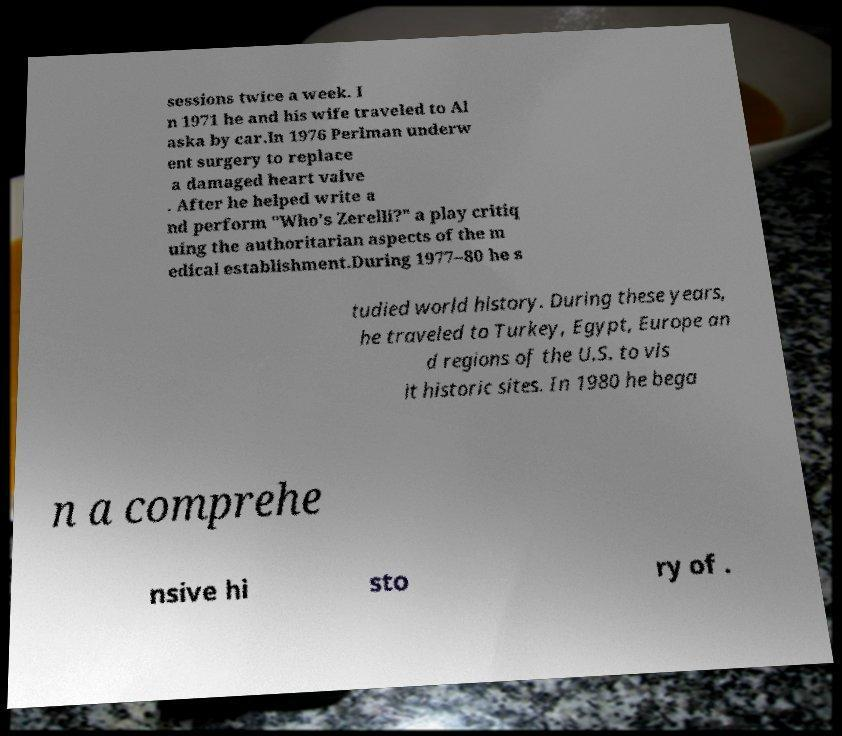Can you accurately transcribe the text from the provided image for me? sessions twice a week. I n 1971 he and his wife traveled to Al aska by car.In 1976 Perlman underw ent surgery to replace a damaged heart valve . After he helped write a nd perform "Who's Zerelli?" a play critiq uing the authoritarian aspects of the m edical establishment.During 1977–80 he s tudied world history. During these years, he traveled to Turkey, Egypt, Europe an d regions of the U.S. to vis it historic sites. In 1980 he bega n a comprehe nsive hi sto ry of . 